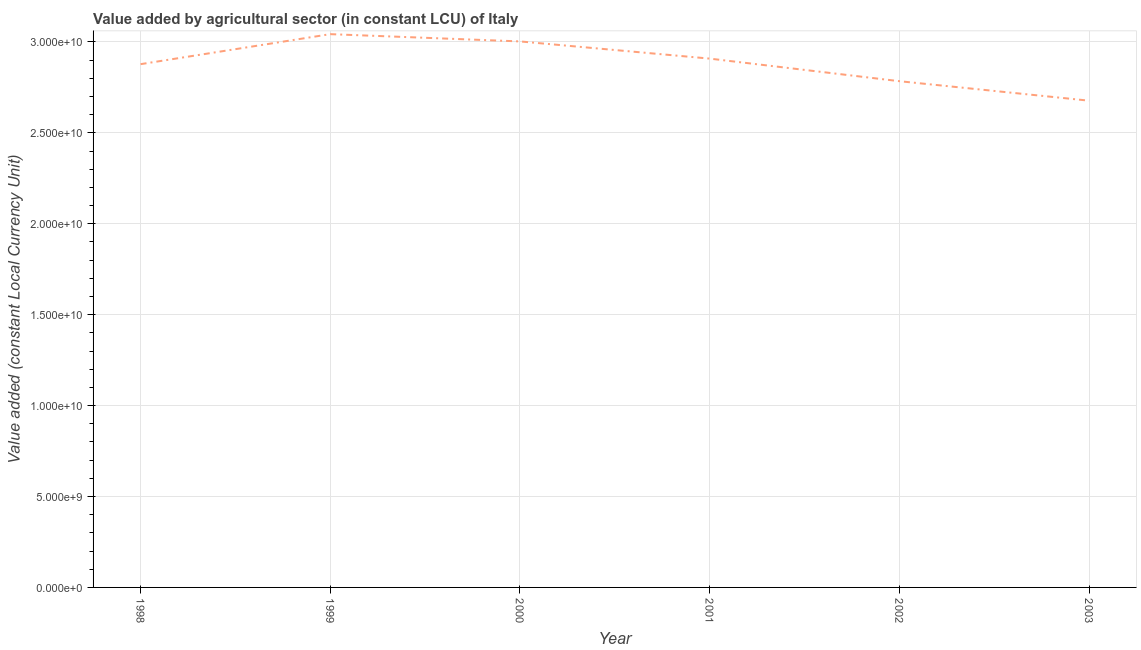What is the value added by agriculture sector in 2003?
Give a very brief answer. 2.68e+1. Across all years, what is the maximum value added by agriculture sector?
Give a very brief answer. 3.04e+1. Across all years, what is the minimum value added by agriculture sector?
Your answer should be very brief. 2.68e+1. What is the sum of the value added by agriculture sector?
Make the answer very short. 1.73e+11. What is the difference between the value added by agriculture sector in 1999 and 2000?
Your response must be concise. 4.00e+08. What is the average value added by agriculture sector per year?
Provide a succinct answer. 2.88e+1. What is the median value added by agriculture sector?
Give a very brief answer. 2.89e+1. In how many years, is the value added by agriculture sector greater than 11000000000 LCU?
Provide a short and direct response. 6. Do a majority of the years between 2003 and 2000 (inclusive) have value added by agriculture sector greater than 15000000000 LCU?
Provide a succinct answer. Yes. What is the ratio of the value added by agriculture sector in 1999 to that in 2001?
Make the answer very short. 1.05. Is the value added by agriculture sector in 1998 less than that in 2002?
Make the answer very short. No. What is the difference between the highest and the second highest value added by agriculture sector?
Ensure brevity in your answer.  4.00e+08. Is the sum of the value added by agriculture sector in 1998 and 2003 greater than the maximum value added by agriculture sector across all years?
Ensure brevity in your answer.  Yes. What is the difference between the highest and the lowest value added by agriculture sector?
Your answer should be compact. 3.66e+09. Does the value added by agriculture sector monotonically increase over the years?
Keep it short and to the point. No. How many lines are there?
Keep it short and to the point. 1. Are the values on the major ticks of Y-axis written in scientific E-notation?
Ensure brevity in your answer.  Yes. What is the title of the graph?
Offer a terse response. Value added by agricultural sector (in constant LCU) of Italy. What is the label or title of the Y-axis?
Provide a short and direct response. Value added (constant Local Currency Unit). What is the Value added (constant Local Currency Unit) in 1998?
Give a very brief answer. 2.88e+1. What is the Value added (constant Local Currency Unit) in 1999?
Your answer should be very brief. 3.04e+1. What is the Value added (constant Local Currency Unit) of 2000?
Make the answer very short. 3.00e+1. What is the Value added (constant Local Currency Unit) in 2001?
Offer a very short reply. 2.91e+1. What is the Value added (constant Local Currency Unit) in 2002?
Offer a terse response. 2.78e+1. What is the Value added (constant Local Currency Unit) in 2003?
Keep it short and to the point. 2.68e+1. What is the difference between the Value added (constant Local Currency Unit) in 1998 and 1999?
Ensure brevity in your answer.  -1.65e+09. What is the difference between the Value added (constant Local Currency Unit) in 1998 and 2000?
Your answer should be compact. -1.25e+09. What is the difference between the Value added (constant Local Currency Unit) in 1998 and 2001?
Offer a very short reply. -3.05e+08. What is the difference between the Value added (constant Local Currency Unit) in 1998 and 2002?
Your answer should be compact. 9.37e+08. What is the difference between the Value added (constant Local Currency Unit) in 1998 and 2003?
Keep it short and to the point. 2.01e+09. What is the difference between the Value added (constant Local Currency Unit) in 1999 and 2000?
Your answer should be very brief. 4.00e+08. What is the difference between the Value added (constant Local Currency Unit) in 1999 and 2001?
Give a very brief answer. 1.34e+09. What is the difference between the Value added (constant Local Currency Unit) in 1999 and 2002?
Your answer should be very brief. 2.59e+09. What is the difference between the Value added (constant Local Currency Unit) in 1999 and 2003?
Ensure brevity in your answer.  3.66e+09. What is the difference between the Value added (constant Local Currency Unit) in 2000 and 2001?
Provide a succinct answer. 9.45e+08. What is the difference between the Value added (constant Local Currency Unit) in 2000 and 2002?
Provide a short and direct response. 2.19e+09. What is the difference between the Value added (constant Local Currency Unit) in 2000 and 2003?
Make the answer very short. 3.26e+09. What is the difference between the Value added (constant Local Currency Unit) in 2001 and 2002?
Your answer should be compact. 1.24e+09. What is the difference between the Value added (constant Local Currency Unit) in 2001 and 2003?
Keep it short and to the point. 2.31e+09. What is the difference between the Value added (constant Local Currency Unit) in 2002 and 2003?
Provide a short and direct response. 1.07e+09. What is the ratio of the Value added (constant Local Currency Unit) in 1998 to that in 1999?
Your answer should be compact. 0.95. What is the ratio of the Value added (constant Local Currency Unit) in 1998 to that in 2000?
Offer a terse response. 0.96. What is the ratio of the Value added (constant Local Currency Unit) in 1998 to that in 2001?
Your answer should be compact. 0.99. What is the ratio of the Value added (constant Local Currency Unit) in 1998 to that in 2002?
Keep it short and to the point. 1.03. What is the ratio of the Value added (constant Local Currency Unit) in 1998 to that in 2003?
Offer a terse response. 1.07. What is the ratio of the Value added (constant Local Currency Unit) in 1999 to that in 2001?
Your answer should be compact. 1.05. What is the ratio of the Value added (constant Local Currency Unit) in 1999 to that in 2002?
Offer a very short reply. 1.09. What is the ratio of the Value added (constant Local Currency Unit) in 1999 to that in 2003?
Offer a terse response. 1.14. What is the ratio of the Value added (constant Local Currency Unit) in 2000 to that in 2001?
Ensure brevity in your answer.  1.03. What is the ratio of the Value added (constant Local Currency Unit) in 2000 to that in 2002?
Provide a short and direct response. 1.08. What is the ratio of the Value added (constant Local Currency Unit) in 2000 to that in 2003?
Offer a very short reply. 1.12. What is the ratio of the Value added (constant Local Currency Unit) in 2001 to that in 2002?
Your answer should be very brief. 1.04. What is the ratio of the Value added (constant Local Currency Unit) in 2001 to that in 2003?
Make the answer very short. 1.09. 